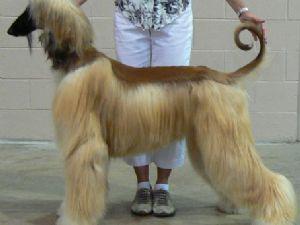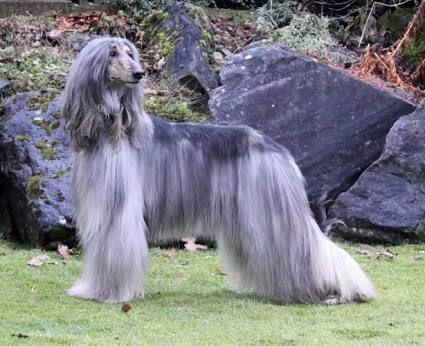The first image is the image on the left, the second image is the image on the right. For the images shown, is this caption "At least one afghan hound with a curled upright tail is standing in profile." true? Answer yes or no. Yes. 